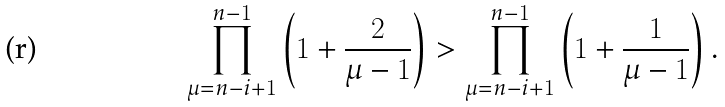Convert formula to latex. <formula><loc_0><loc_0><loc_500><loc_500>\prod _ { \mu = n - i + 1 } ^ { n - 1 } \left ( 1 + \frac { 2 } { \mu - 1 } \right ) > \prod _ { \mu = n - i + 1 } ^ { n - 1 } \left ( 1 + \frac { 1 } { \mu - 1 } \right ) .</formula> 